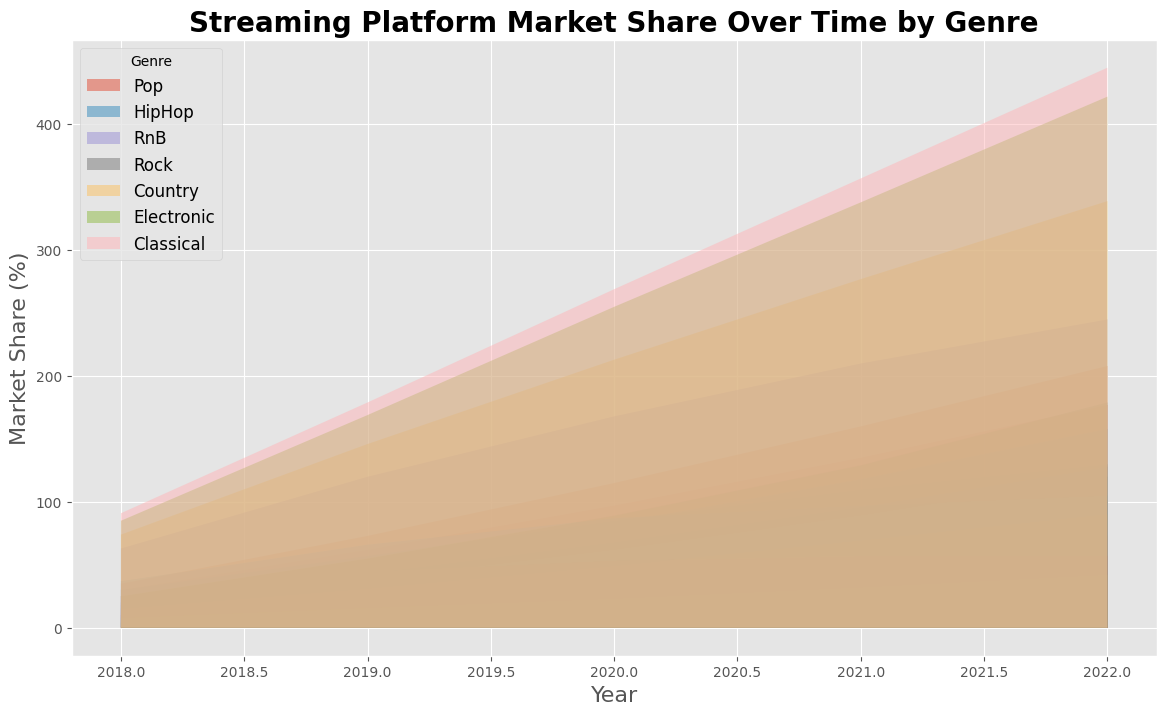Which platform showed the highest increase in Pop genre market share from 2018 to 2022? To find the platform with the highest increase in Pop genre market share, compare the values in 2018 and 2022 for each platform. Spotify increased from 35% to 48%, Apple Music from 30% to 42%, Amazon Music from 10% to 20%, and 'Other' from 25% to 0%. Spotify had the highest increase.
Answer: Spotify How did Apple Music's HipHop market share change from 2018 to 2022? Look at Apple Music’s HipHop percentages in 2018 (20%) and in 2022 (32%). Calculate the change as 32% - 20% = 12%.
Answer: Increased by 12% Which genre had the least variability in market share for Spotify from 2018 to 2022? Determine the range of values for each genre's market share on Spotify from 2018 to 2022 and compare them. Pop varies from 35% to 48%, HipHop from 25% to 40%, RnB from 10% to 20%, Rock from 15% to 20%, Country from 5% to 9%, Electronic from 3% to 4%, and Classical from 1% to 2%. Classical has the least variability.
Answer: Classical What was the combined market share of Amazon Music for the genres HipHop and Electronic in 2021? Locate the values for HipHop (27%) and Electronic (9%) in 2021 for Amazon Music. Sum these values: 27% + 9% = 36%.
Answer: 36% Which genre consistently held the highest market share in the 'Other' platform from 2018 to 2022? Compare the market share values of all genres for the 'Other' platform across the years. Classical stays highest within 'Other': 91% (2018), 88% (2019), 90% (2020), 88% (2021), 88% (2022).
Answer: Classical Is there any year where Amazon Music had more RnB market share than Apple Music? Compare the annual market shares of RnB for Amazon Music and Apple Music. Check the values for each year: 2018: 12 (Amazon), 15 (Apple); 2019: 14 (Amazon), 17 (Apple); 2020: 16 (Amazon), 20 (Apple); 2021: 18 (Amazon), 22 (Apple); 2022: 20 (Amazon), 25 (Apple). There was no year where Amazon Music had more RnB market share.
Answer: No From 2018 to 2022, which year did the 'Other' platform have the lowest market share in the HipHop genre? Review the HipHop market share for the 'Other' platform: 37% (2018), 29% (2019), 21% (2020), 10% (2021), 8% (2022). The lowest is in 2022.
Answer: 2022 